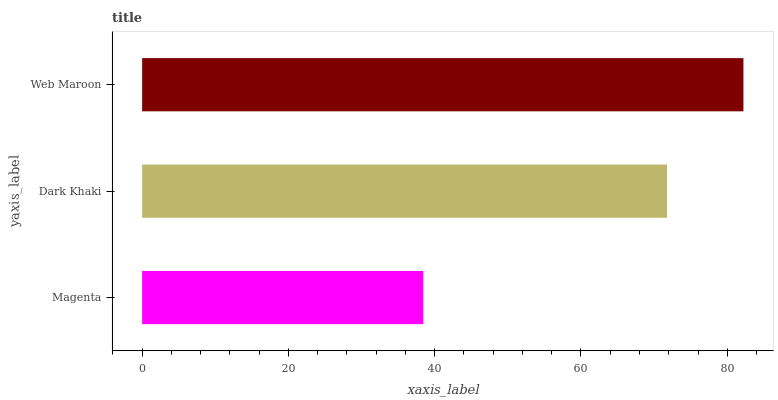Is Magenta the minimum?
Answer yes or no. Yes. Is Web Maroon the maximum?
Answer yes or no. Yes. Is Dark Khaki the minimum?
Answer yes or no. No. Is Dark Khaki the maximum?
Answer yes or no. No. Is Dark Khaki greater than Magenta?
Answer yes or no. Yes. Is Magenta less than Dark Khaki?
Answer yes or no. Yes. Is Magenta greater than Dark Khaki?
Answer yes or no. No. Is Dark Khaki less than Magenta?
Answer yes or no. No. Is Dark Khaki the high median?
Answer yes or no. Yes. Is Dark Khaki the low median?
Answer yes or no. Yes. Is Magenta the high median?
Answer yes or no. No. Is Web Maroon the low median?
Answer yes or no. No. 